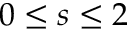Convert formula to latex. <formula><loc_0><loc_0><loc_500><loc_500>0 \leq s \leq 2</formula> 